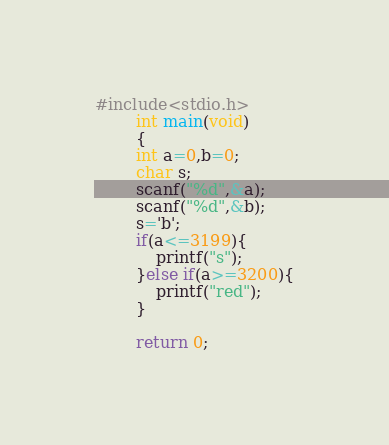Convert code to text. <code><loc_0><loc_0><loc_500><loc_500><_C_>#include<stdio.h>
		int main(void)
		{
		int a=0,b=0;
		char s;
		scanf("%d",&a);
		scanf("%d",&b);
		s='b';
		if(a<=3199){
			printf("s");
		}else if(a>=3200){
			printf("red");
		}
		
		return 0;</code> 